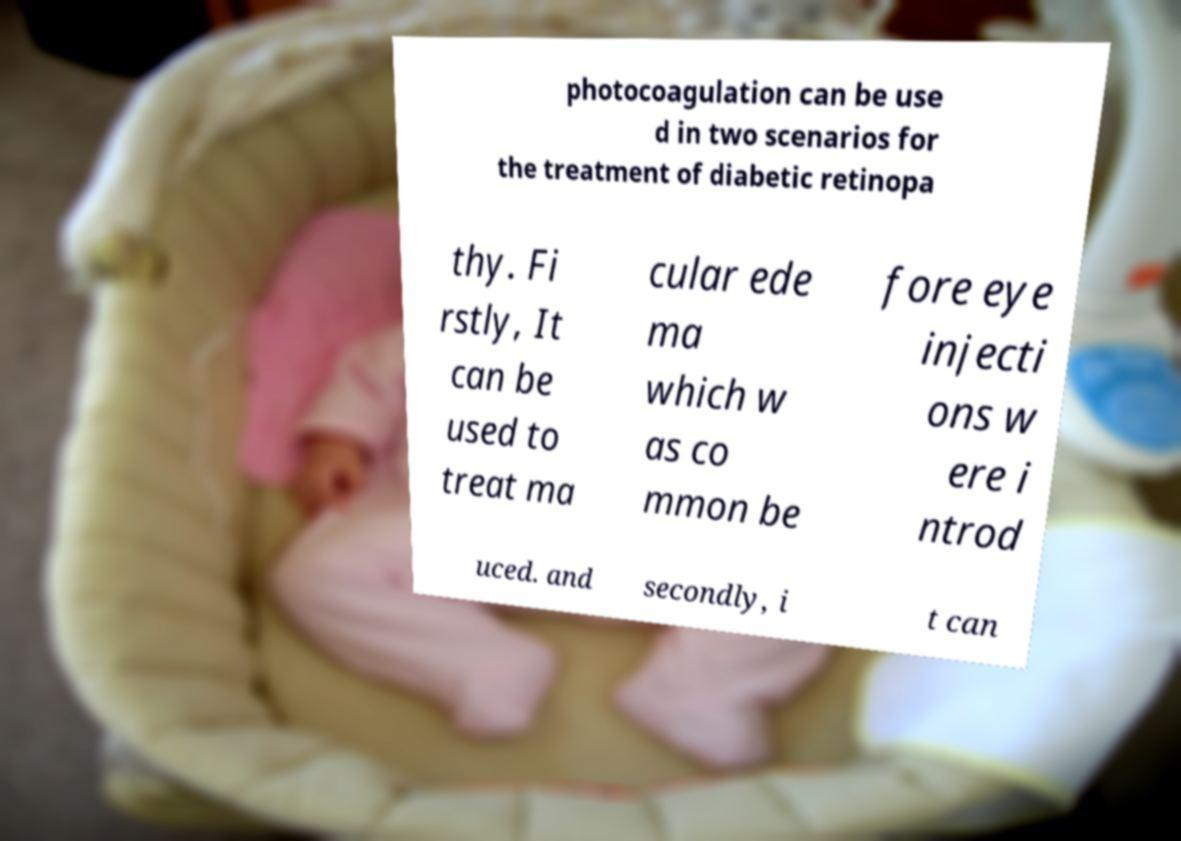Could you extract and type out the text from this image? photocoagulation can be use d in two scenarios for the treatment of diabetic retinopa thy. Fi rstly, It can be used to treat ma cular ede ma which w as co mmon be fore eye injecti ons w ere i ntrod uced. and secondly, i t can 